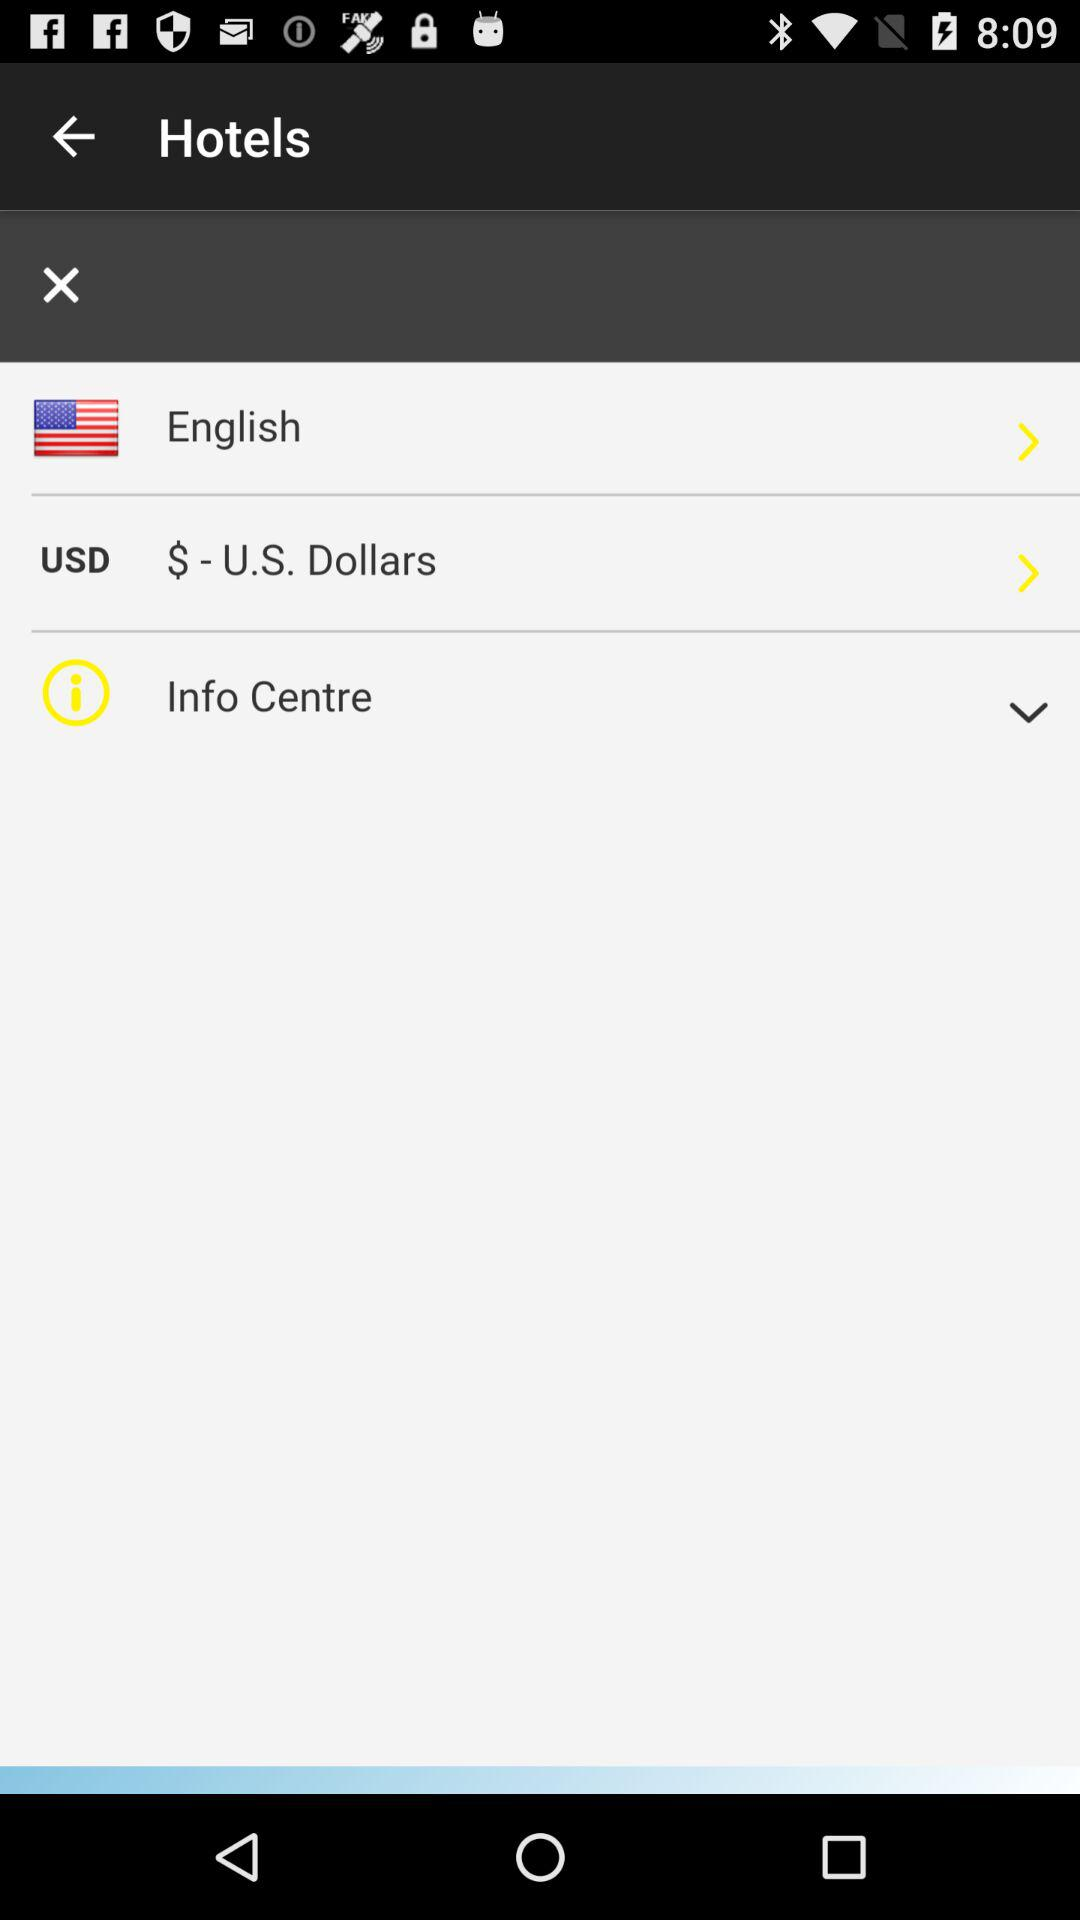Which currency is used? The currency is $-U.S. Dollars. 